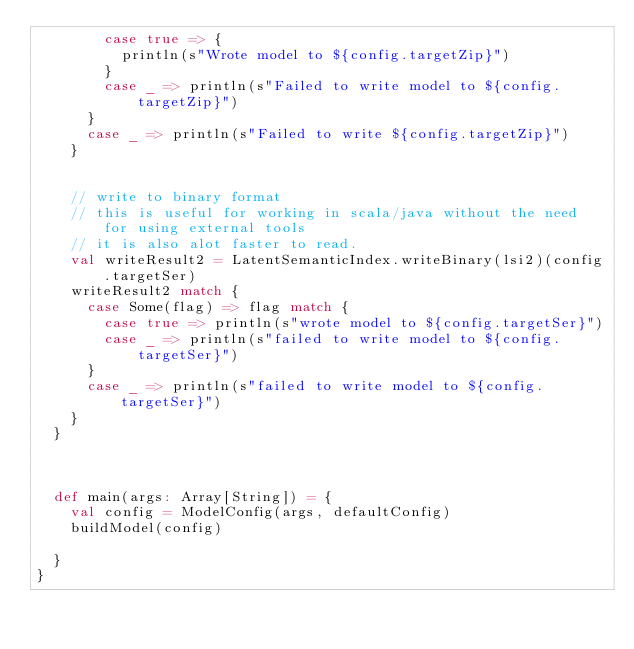<code> <loc_0><loc_0><loc_500><loc_500><_Scala_>        case true => {
          println(s"Wrote model to ${config.targetZip}")
        }
        case _ => println(s"Failed to write model to ${config.targetZip}")
      }
      case _ => println(s"Failed to write ${config.targetZip}")
    }


    // write to binary format
    // this is useful for working in scala/java without the need for using external tools
    // it is also alot faster to read.
    val writeResult2 = LatentSemanticIndex.writeBinary(lsi2)(config.targetSer)
    writeResult2 match {
      case Some(flag) => flag match {
        case true => println(s"wrote model to ${config.targetSer}")
        case _ => println(s"failed to write model to ${config.targetSer}")
      }
      case _ => println(s"failed to write model to ${config.targetSer}")
    }
  }



  def main(args: Array[String]) = {
    val config = ModelConfig(args, defaultConfig)
    buildModel(config)

  }
}
</code> 